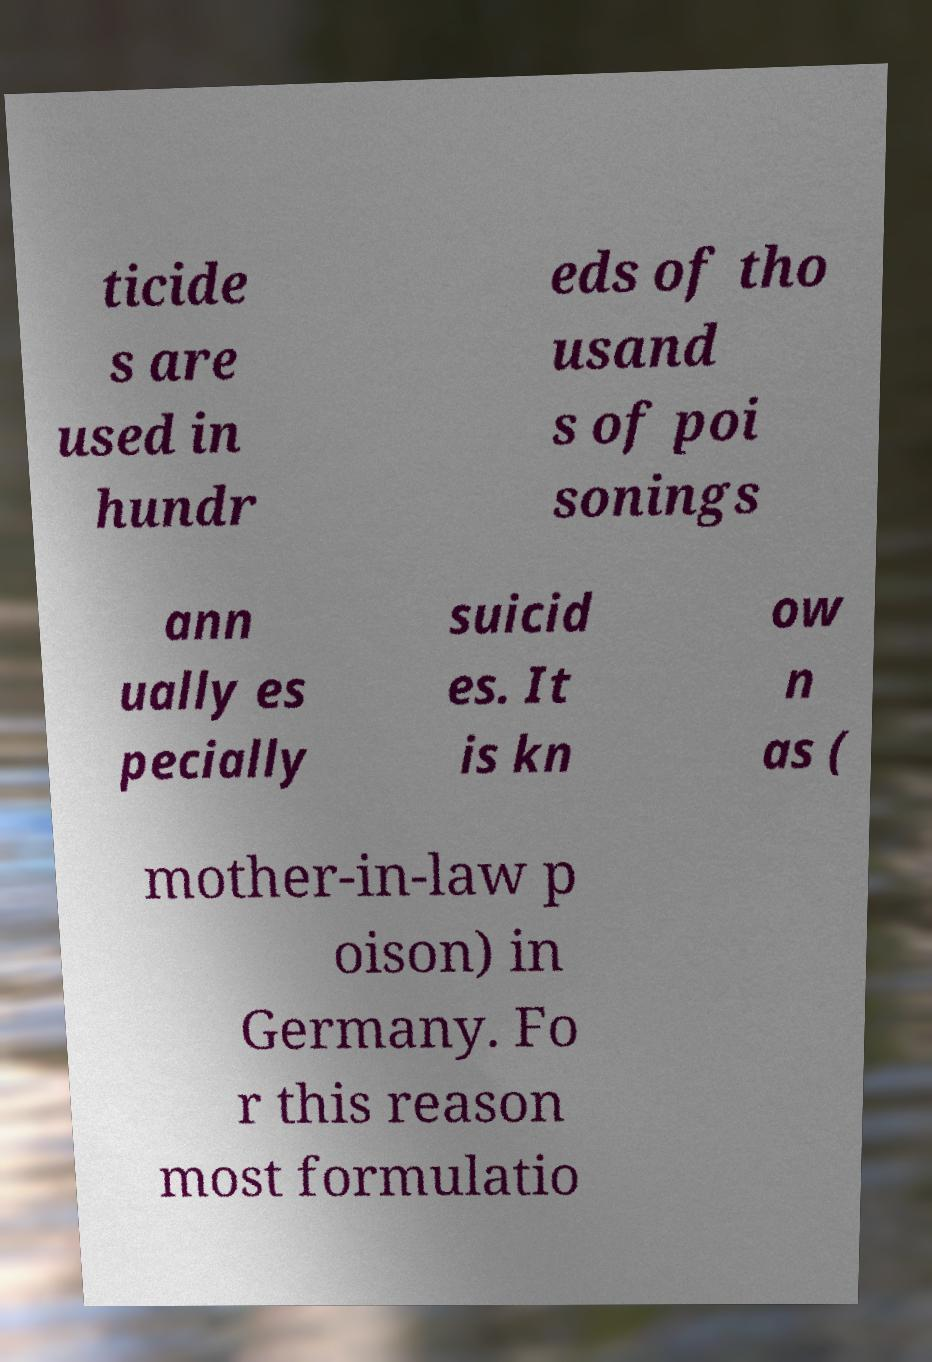For documentation purposes, I need the text within this image transcribed. Could you provide that? ticide s are used in hundr eds of tho usand s of poi sonings ann ually es pecially suicid es. It is kn ow n as ( mother-in-law p oison) in Germany. Fo r this reason most formulatio 